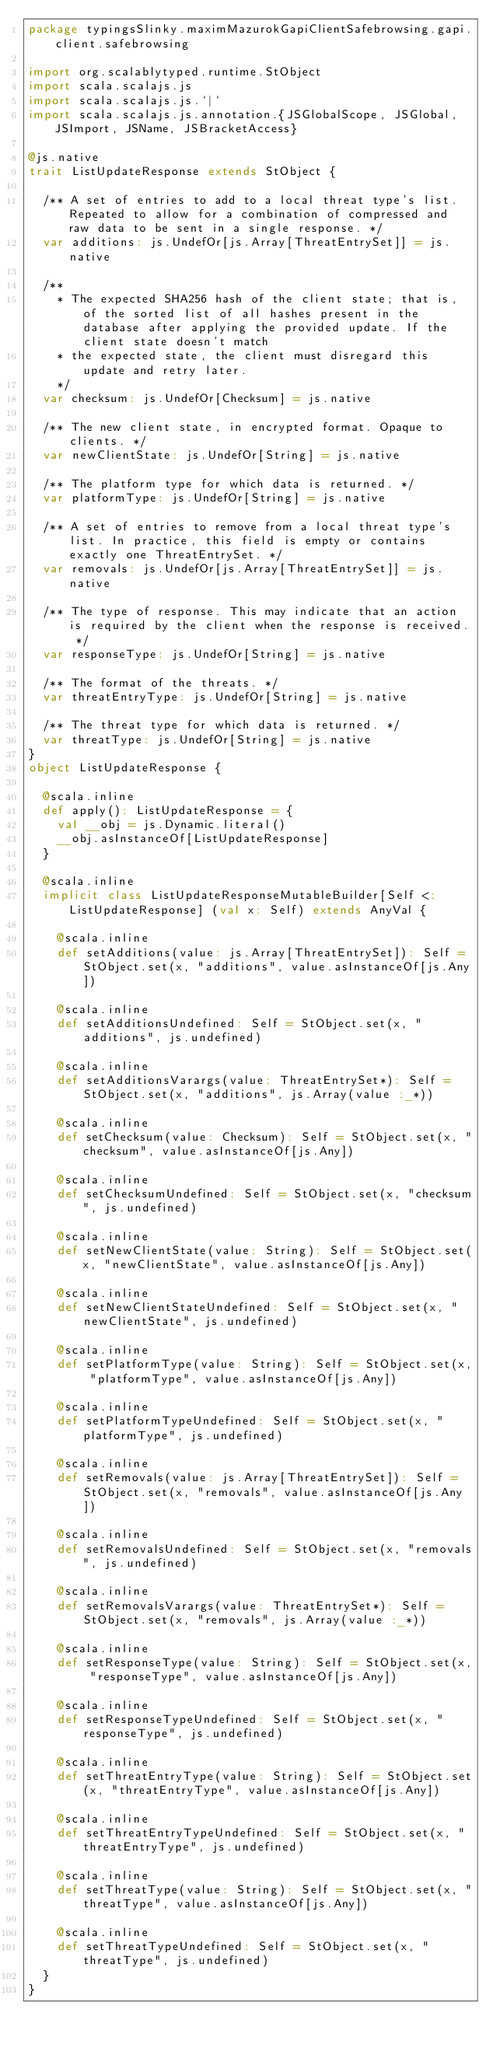Convert code to text. <code><loc_0><loc_0><loc_500><loc_500><_Scala_>package typingsSlinky.maximMazurokGapiClientSafebrowsing.gapi.client.safebrowsing

import org.scalablytyped.runtime.StObject
import scala.scalajs.js
import scala.scalajs.js.`|`
import scala.scalajs.js.annotation.{JSGlobalScope, JSGlobal, JSImport, JSName, JSBracketAccess}

@js.native
trait ListUpdateResponse extends StObject {
  
  /** A set of entries to add to a local threat type's list. Repeated to allow for a combination of compressed and raw data to be sent in a single response. */
  var additions: js.UndefOr[js.Array[ThreatEntrySet]] = js.native
  
  /**
    * The expected SHA256 hash of the client state; that is, of the sorted list of all hashes present in the database after applying the provided update. If the client state doesn't match
    * the expected state, the client must disregard this update and retry later.
    */
  var checksum: js.UndefOr[Checksum] = js.native
  
  /** The new client state, in encrypted format. Opaque to clients. */
  var newClientState: js.UndefOr[String] = js.native
  
  /** The platform type for which data is returned. */
  var platformType: js.UndefOr[String] = js.native
  
  /** A set of entries to remove from a local threat type's list. In practice, this field is empty or contains exactly one ThreatEntrySet. */
  var removals: js.UndefOr[js.Array[ThreatEntrySet]] = js.native
  
  /** The type of response. This may indicate that an action is required by the client when the response is received. */
  var responseType: js.UndefOr[String] = js.native
  
  /** The format of the threats. */
  var threatEntryType: js.UndefOr[String] = js.native
  
  /** The threat type for which data is returned. */
  var threatType: js.UndefOr[String] = js.native
}
object ListUpdateResponse {
  
  @scala.inline
  def apply(): ListUpdateResponse = {
    val __obj = js.Dynamic.literal()
    __obj.asInstanceOf[ListUpdateResponse]
  }
  
  @scala.inline
  implicit class ListUpdateResponseMutableBuilder[Self <: ListUpdateResponse] (val x: Self) extends AnyVal {
    
    @scala.inline
    def setAdditions(value: js.Array[ThreatEntrySet]): Self = StObject.set(x, "additions", value.asInstanceOf[js.Any])
    
    @scala.inline
    def setAdditionsUndefined: Self = StObject.set(x, "additions", js.undefined)
    
    @scala.inline
    def setAdditionsVarargs(value: ThreatEntrySet*): Self = StObject.set(x, "additions", js.Array(value :_*))
    
    @scala.inline
    def setChecksum(value: Checksum): Self = StObject.set(x, "checksum", value.asInstanceOf[js.Any])
    
    @scala.inline
    def setChecksumUndefined: Self = StObject.set(x, "checksum", js.undefined)
    
    @scala.inline
    def setNewClientState(value: String): Self = StObject.set(x, "newClientState", value.asInstanceOf[js.Any])
    
    @scala.inline
    def setNewClientStateUndefined: Self = StObject.set(x, "newClientState", js.undefined)
    
    @scala.inline
    def setPlatformType(value: String): Self = StObject.set(x, "platformType", value.asInstanceOf[js.Any])
    
    @scala.inline
    def setPlatformTypeUndefined: Self = StObject.set(x, "platformType", js.undefined)
    
    @scala.inline
    def setRemovals(value: js.Array[ThreatEntrySet]): Self = StObject.set(x, "removals", value.asInstanceOf[js.Any])
    
    @scala.inline
    def setRemovalsUndefined: Self = StObject.set(x, "removals", js.undefined)
    
    @scala.inline
    def setRemovalsVarargs(value: ThreatEntrySet*): Self = StObject.set(x, "removals", js.Array(value :_*))
    
    @scala.inline
    def setResponseType(value: String): Self = StObject.set(x, "responseType", value.asInstanceOf[js.Any])
    
    @scala.inline
    def setResponseTypeUndefined: Self = StObject.set(x, "responseType", js.undefined)
    
    @scala.inline
    def setThreatEntryType(value: String): Self = StObject.set(x, "threatEntryType", value.asInstanceOf[js.Any])
    
    @scala.inline
    def setThreatEntryTypeUndefined: Self = StObject.set(x, "threatEntryType", js.undefined)
    
    @scala.inline
    def setThreatType(value: String): Self = StObject.set(x, "threatType", value.asInstanceOf[js.Any])
    
    @scala.inline
    def setThreatTypeUndefined: Self = StObject.set(x, "threatType", js.undefined)
  }
}
</code> 